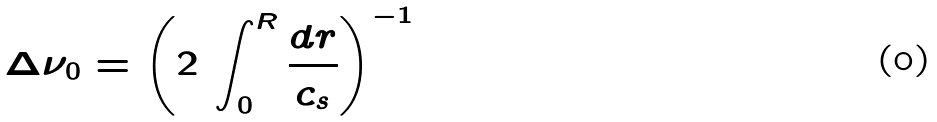<formula> <loc_0><loc_0><loc_500><loc_500>\Delta \nu _ { 0 } = \left ( 2 \, \int _ { 0 } ^ { R } \frac { d r } { c _ { s } } \right ) ^ { - 1 }</formula> 